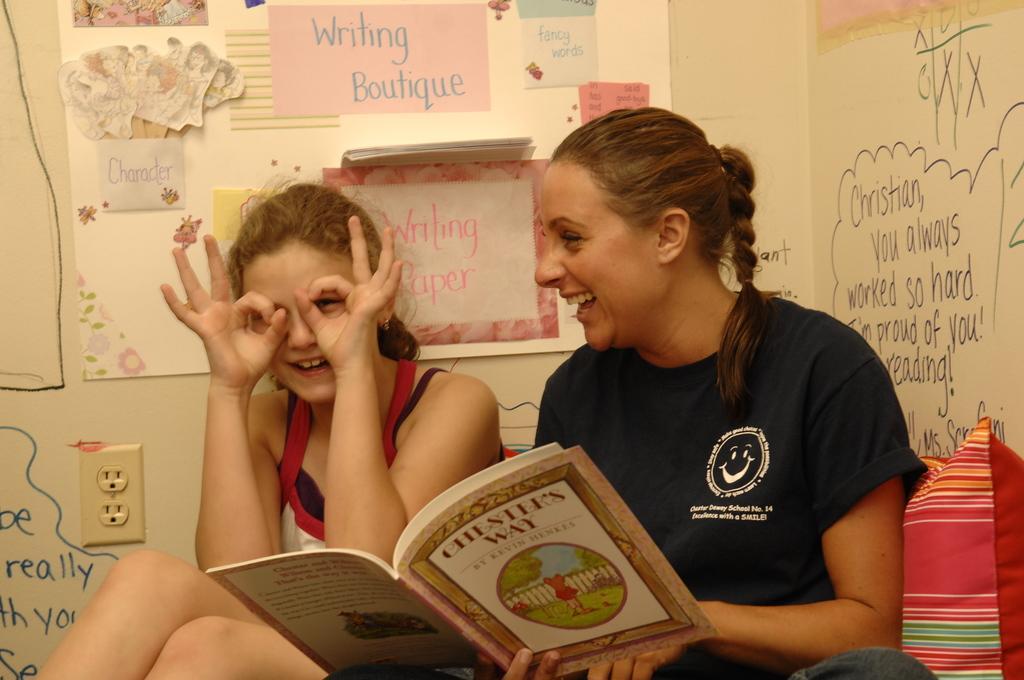How would you summarize this image in a sentence or two? In this picture I can see two persons smiling, there is a person holding a book, there is a pillow, there is a board with papers and there are some scribblings on the wall. 